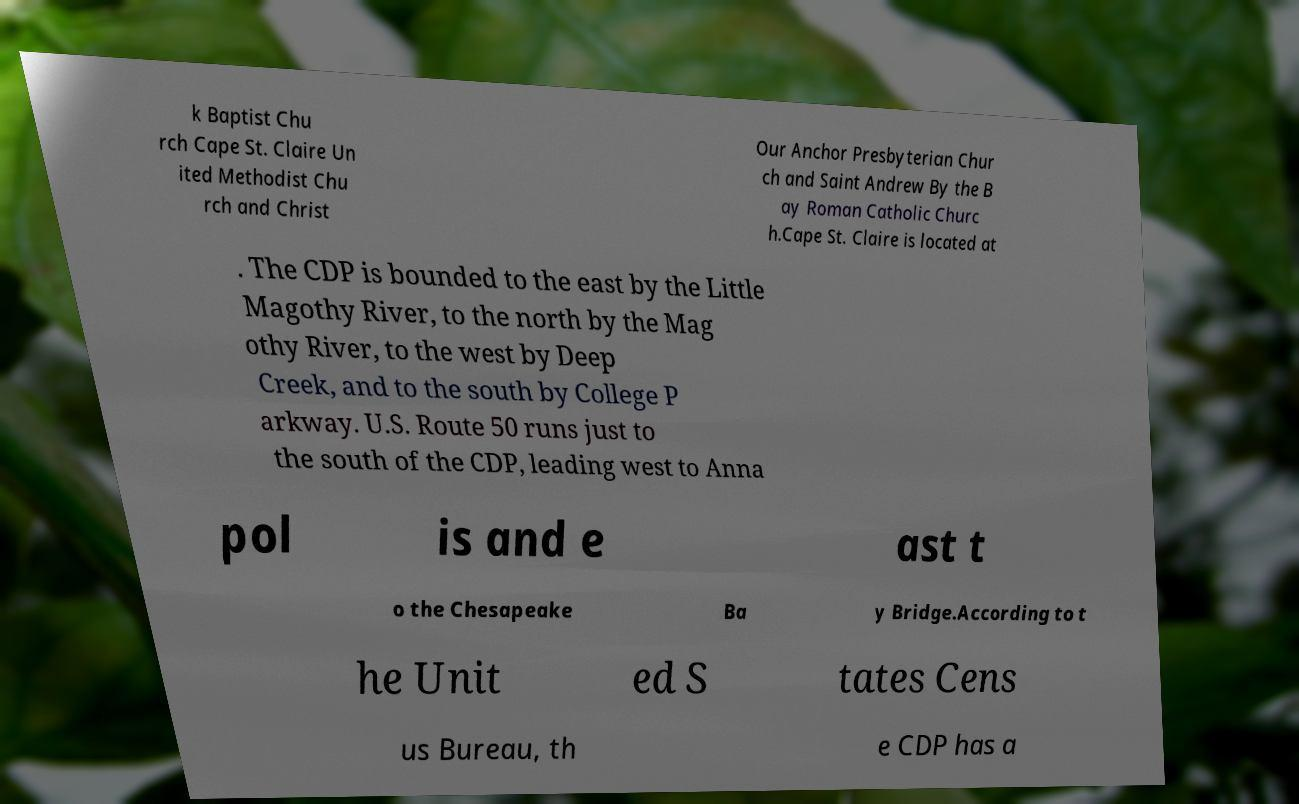Could you assist in decoding the text presented in this image and type it out clearly? k Baptist Chu rch Cape St. Claire Un ited Methodist Chu rch and Christ Our Anchor Presbyterian Chur ch and Saint Andrew By the B ay Roman Catholic Churc h.Cape St. Claire is located at . The CDP is bounded to the east by the Little Magothy River, to the north by the Mag othy River, to the west by Deep Creek, and to the south by College P arkway. U.S. Route 50 runs just to the south of the CDP, leading west to Anna pol is and e ast t o the Chesapeake Ba y Bridge.According to t he Unit ed S tates Cens us Bureau, th e CDP has a 